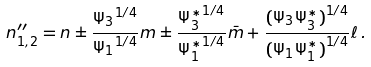Convert formula to latex. <formula><loc_0><loc_0><loc_500><loc_500>n ^ { \prime \prime } _ { 1 , 2 } = n \pm \frac { { \Psi _ { 3 } } ^ { 1 / 4 } } { { \Psi _ { 1 } } ^ { 1 / 4 } } m \pm \frac { { \Psi _ { 3 } ^ { * } } ^ { 1 / 4 } } { { \Psi _ { 1 } ^ { * } } ^ { 1 / 4 } } { \bar { m } } + \frac { { ( \Psi _ { 3 } \Psi _ { 3 } ^ { * } ) } ^ { 1 / 4 } } { { ( \Psi _ { 1 } \Psi _ { 1 } ^ { * } ) } ^ { 1 / 4 } } \ell \, .</formula> 